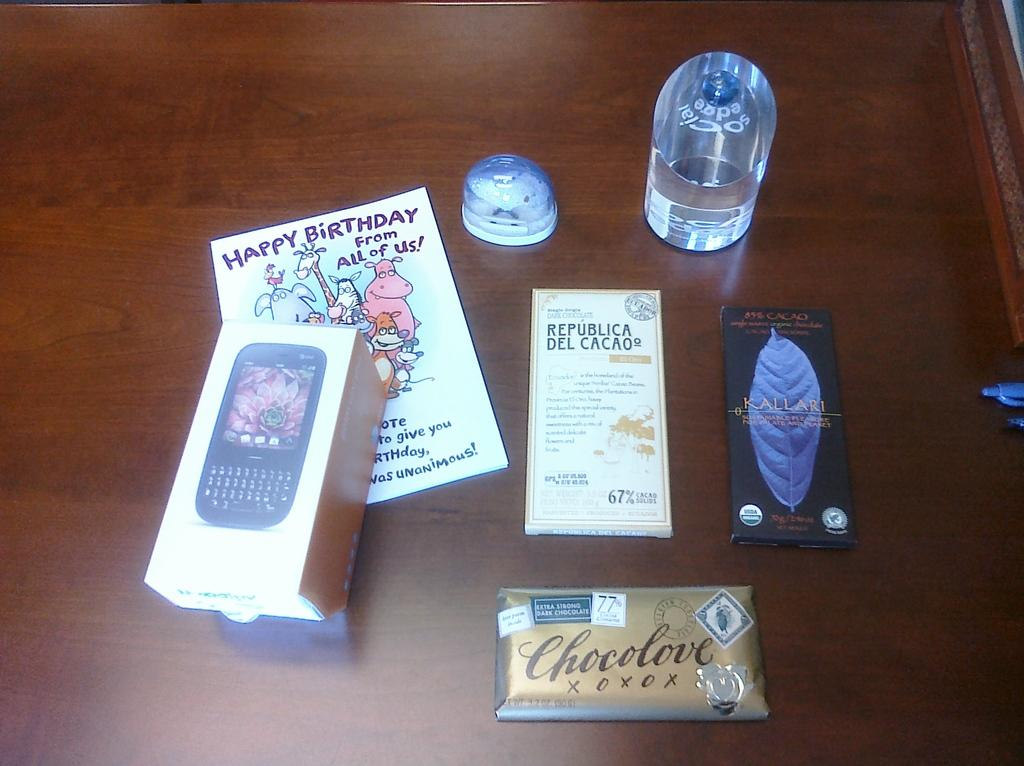What is the main object in the image? There is a cell phone box in the image. What edible items can be seen in the image? There are three chocolates in the image. What writing instrument is present in the image? There is a pen in the image. What type of stationery item is in the image? There is a greeting card in the image. How many unspecified objects are present in the image? There are two other unspecified objects in the image. Where are all the objects placed in the image? All objects are placed on a table. What type of bear can be seen painting on a canvas in the image? There is no bear or canvas present in the image. How many ears of corn are visible in the image? There are no ears of corn present in the image. 